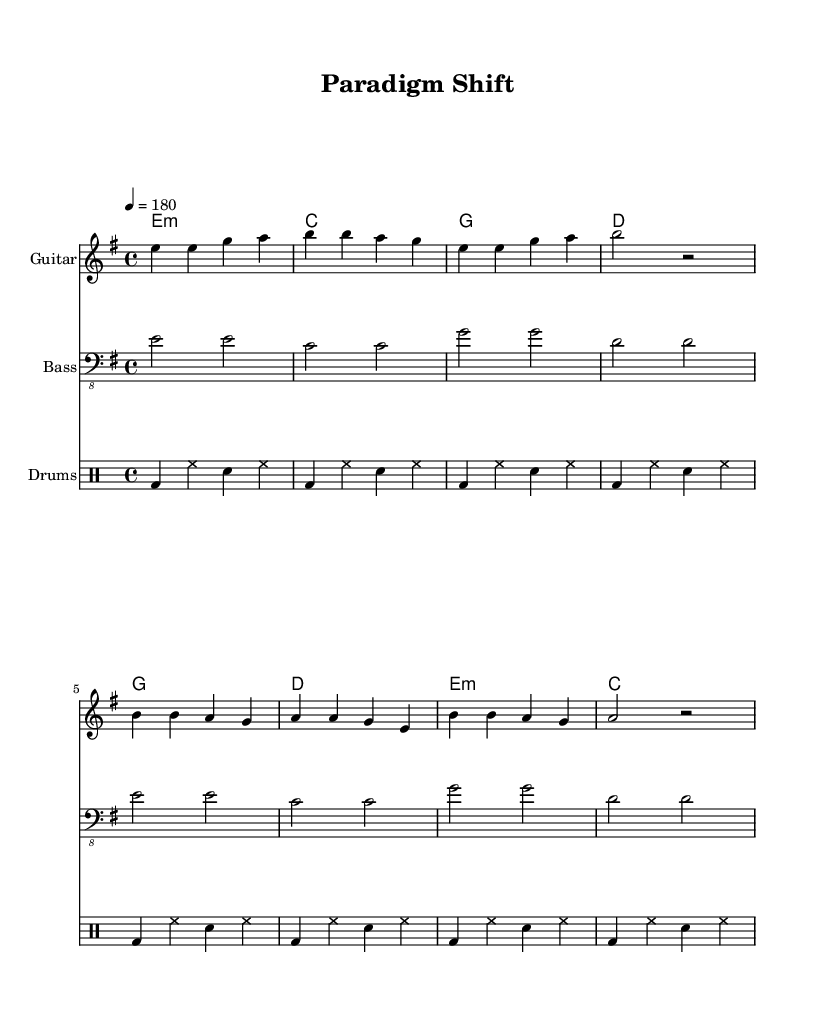What is the key signature of this music? The key signature is E minor, which has one sharp (F#). This can be identified from the key signature notations at the beginning of the staff that signify the notes that are sharpened in this piece.
Answer: E minor What is the time signature of the piece? The time signature is 4/4, which is noted at the beginning of the score. This indicates that there are four beats in each measure and the quarter note gets one beat.
Answer: 4/4 What is the tempo marking for this music? The tempo marking is 180 beats per minute, indicated by the text "4 = 180" at the beginning of the score. This suggests a fast-paced performance.
Answer: 180 How many measures are in the verse? The verse consists of four measures, as shown by the four chord symbols and the corresponding melody notes in the provided music notation. Each section of the verse corresponds to one measure.
Answer: 4 What are the first two words of the chorus? The first two words of the chorus are "Words create," which can be found in the lyrics section under the chorus melody line.
Answer: Words create How does the tempo affect the energy of the punk genre in this piece? The tempo of 180 BPM contributes to a high-energy feel common in punk music. Since punk typically emphasizes speed and aggression, this fast tempo aligns with the genre's characteristics, encouraging an invigorating pace.
Answer: High-energy What is the role of lyrics in this piece's message? The lyrics focus on deconstructing Darwin’s theory through a linguistic perspective, intending to critique and reinterpret scientific discourse, which reflects the rebellious spirit inherent in punk music by challenging established norms.
Answer: Critique scientific discourse 